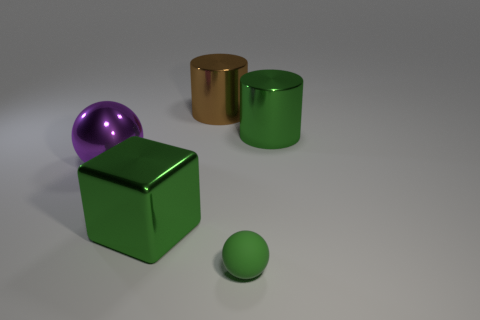Can you assume the relative sizes of the objects based on the image? Based on their appearance in the image and assuming they are at similar distances from the viewer, the green cube appears to be the largest object in terms of volume. The brown cylinder and green cylinder seem to be of medium size, with the brown cylinder being the tallest. The purple sphere and the small green sphere are the smallest objects, with the green sphere being slightly smaller than the purple sphere. 